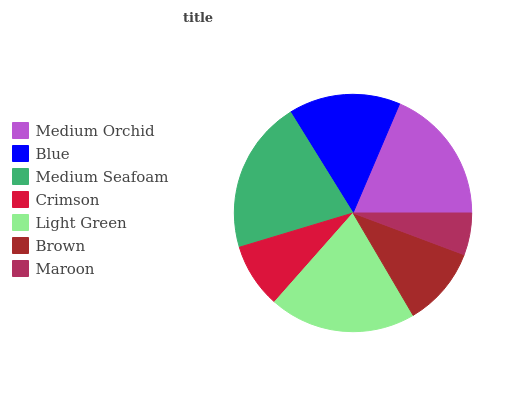Is Maroon the minimum?
Answer yes or no. Yes. Is Medium Seafoam the maximum?
Answer yes or no. Yes. Is Blue the minimum?
Answer yes or no. No. Is Blue the maximum?
Answer yes or no. No. Is Medium Orchid greater than Blue?
Answer yes or no. Yes. Is Blue less than Medium Orchid?
Answer yes or no. Yes. Is Blue greater than Medium Orchid?
Answer yes or no. No. Is Medium Orchid less than Blue?
Answer yes or no. No. Is Blue the high median?
Answer yes or no. Yes. Is Blue the low median?
Answer yes or no. Yes. Is Crimson the high median?
Answer yes or no. No. Is Crimson the low median?
Answer yes or no. No. 